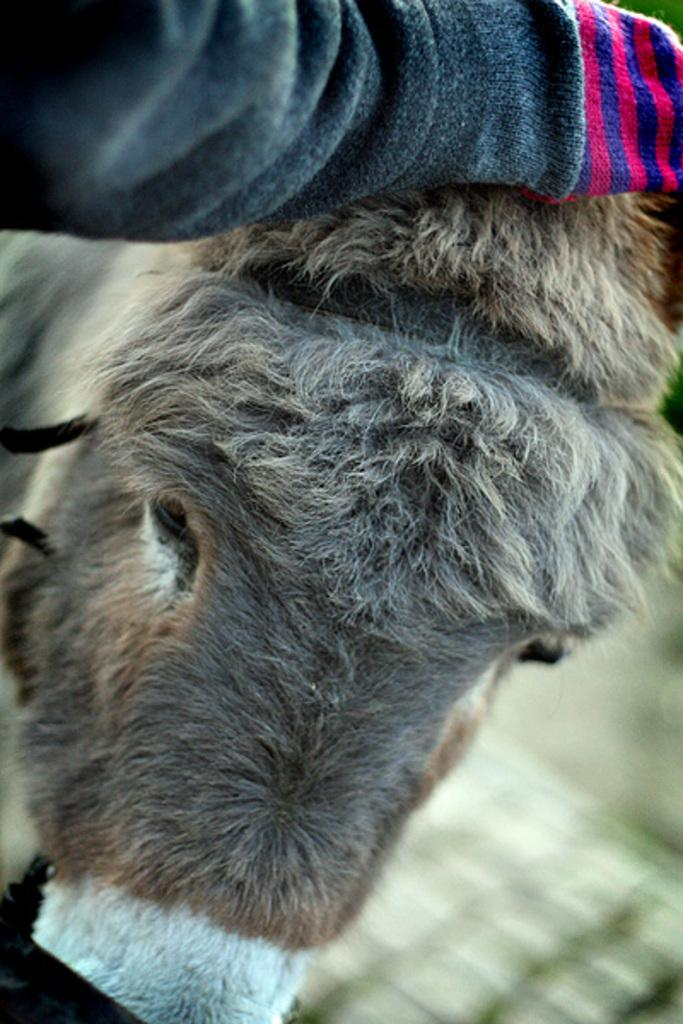What type of animal is present in the image? There is a donkey in the image. How many pages does the donkey have in the image? There are no pages present in the image, as it features a donkey. What type of bird is sitting on the donkey's back in the image? There is no bird present in the image, as it only features a donkey. 